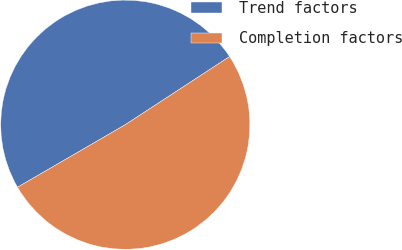Convert chart. <chart><loc_0><loc_0><loc_500><loc_500><pie_chart><fcel>Trend factors<fcel>Completion factors<nl><fcel>49.16%<fcel>50.84%<nl></chart> 